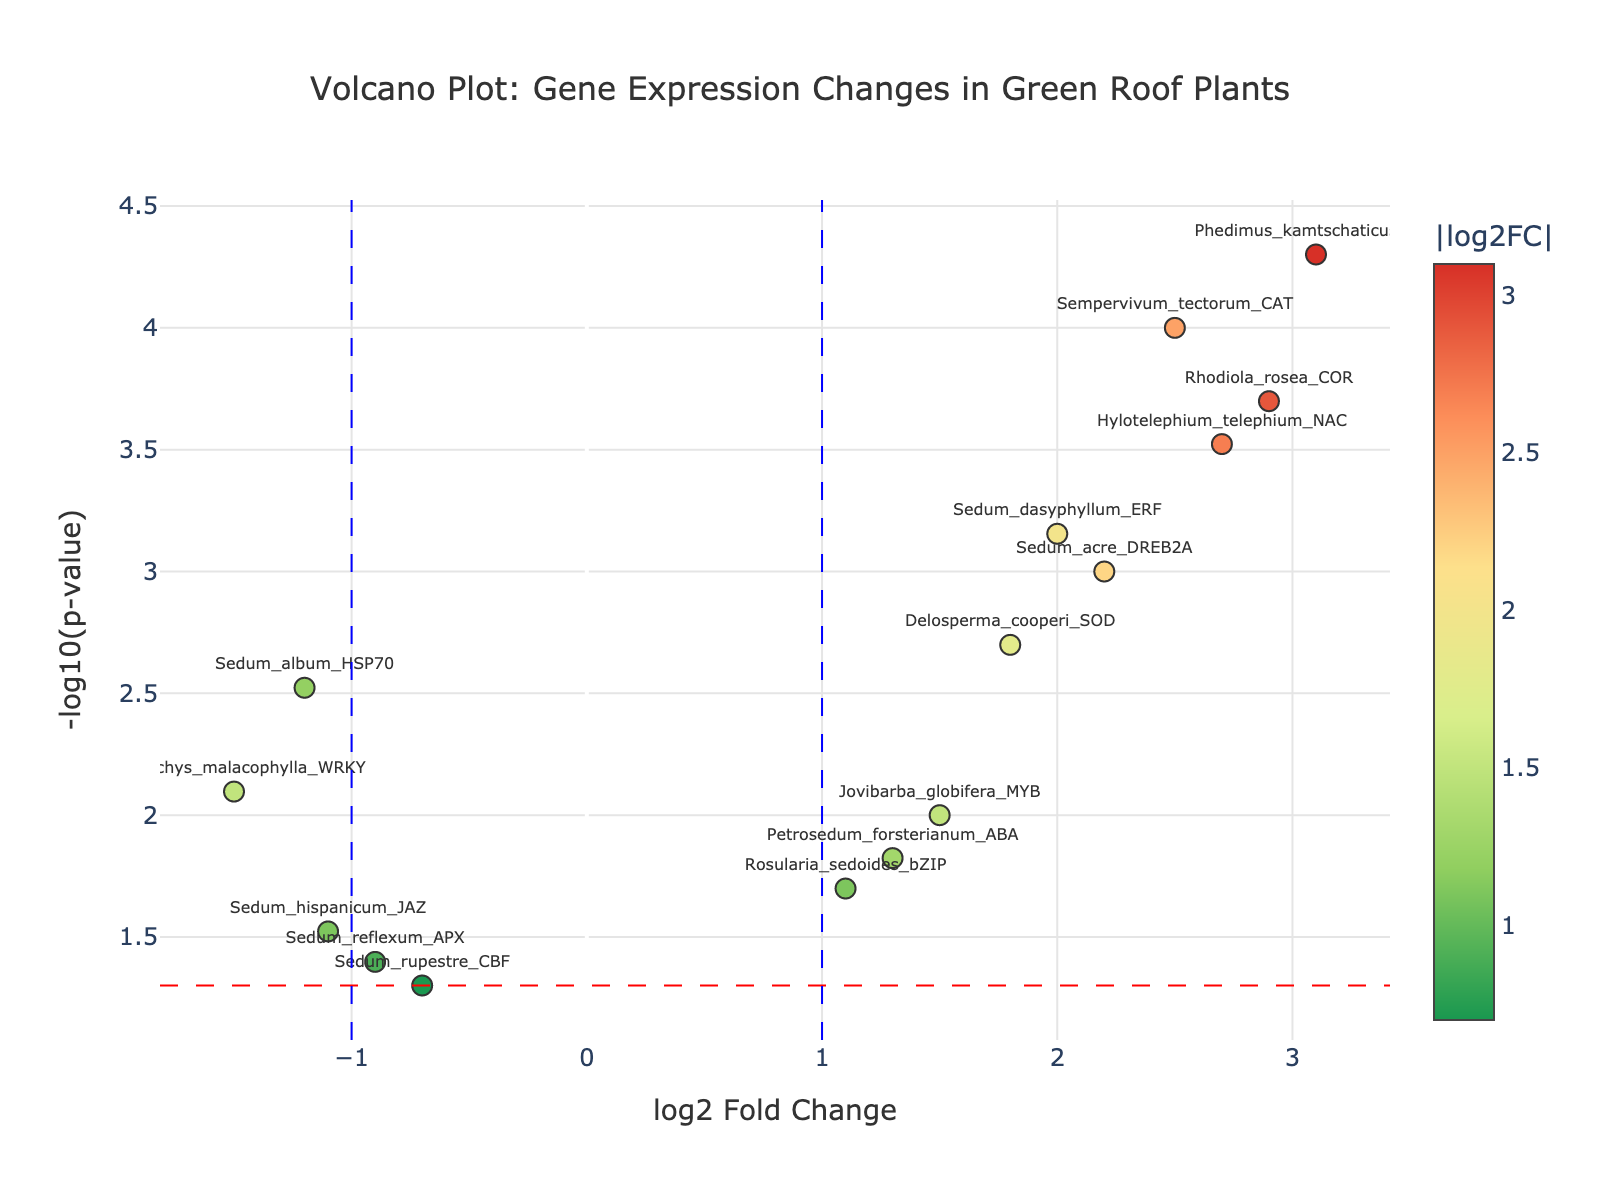How many genes are shown in the volcano plot? Count the number of unique genes listed. The provided data shows 15 unique genes.
Answer: 15 What's the title of the volcano plot? The title is displayed at the top center of the plot. The given code sets the title to "Volcano Plot: Gene Expression Changes in Green Roof Plants."
Answer: Volcano Plot: Gene Expression Changes in Green Roof Plants Which gene has the highest -log10(p-value)? Look for the gene with the highest value on the y-axis representing -log10(p-value). This value indicates the statistical significance of each gene's expression. Phedimus_kamtschaticus_LEA has the highest -log10(p-value).
Answer: Phedimus_kamtschaticus_LEA Which genes have a log2 fold change greater than 2? Identify the genes located to the right of the vertical blue line at log2 fold change = 2 on the x-axis. Sempervivum_tectorum_CAT, Phedimus_kamtschaticus_LEA, Hylotelephium_telephium_NAC, and Rhodiola_rosea_COR have a log2 fold change greater than 2.
Answer: Sempervivum_tectorum_CAT, Phedimus_kamtschaticus_LEA, Hylotelephium_telephium_NAC, Rhodiola_rosea_COR What color scale is used in the plot? The plot uses a gradient color scale from green to red, representing the absolute values of log2 fold change.
Answer: Green to red gradient Which gene has the lowest log2 fold change? Look at the x-axis and identify the gene with the smallest (most negative) log2 fold change value, which is Orostachys_malacophylla_WRKY at -1.5.
Answer: Orostachys_malacophylla_WRKY How many genes have a p-value less than 0.05? Count the genes above the horizontal red line representing the significance threshold of -log10(0.05). There are 13 genes with p-values less than 0.05.
Answer: 13 Which genes fall within the non-significant range for both log2 fold change and p-value? Identify genes that are both between -1 and 1 on the x-axis and below the horizontal red line on the y-axis. Sedum_reflexum_APX and Sedum_rupestre_CBF fall within this range.
Answer: Sedum_reflexum_APX, Sedum_rupestre_CBF Which gene has both high statistical significance and a high positive log2 fold change? Look for genes that are high on the y-axis (significant) and far to the right on the x-axis (high positive log2 fold change). Phedimus_kamtschaticus_LEA fits both criteria.
Answer: Phedimus_kamtschaticus_LEA 